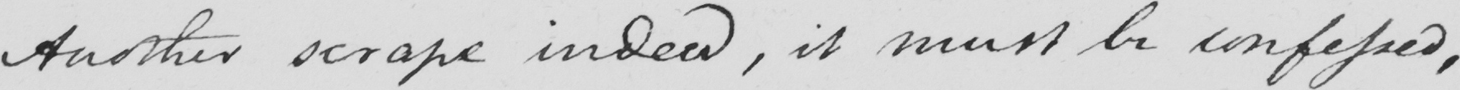Can you tell me what this handwritten text says? Another scrape indeed , it must be confessed , 